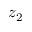<formula> <loc_0><loc_0><loc_500><loc_500>z _ { 2 }</formula> 